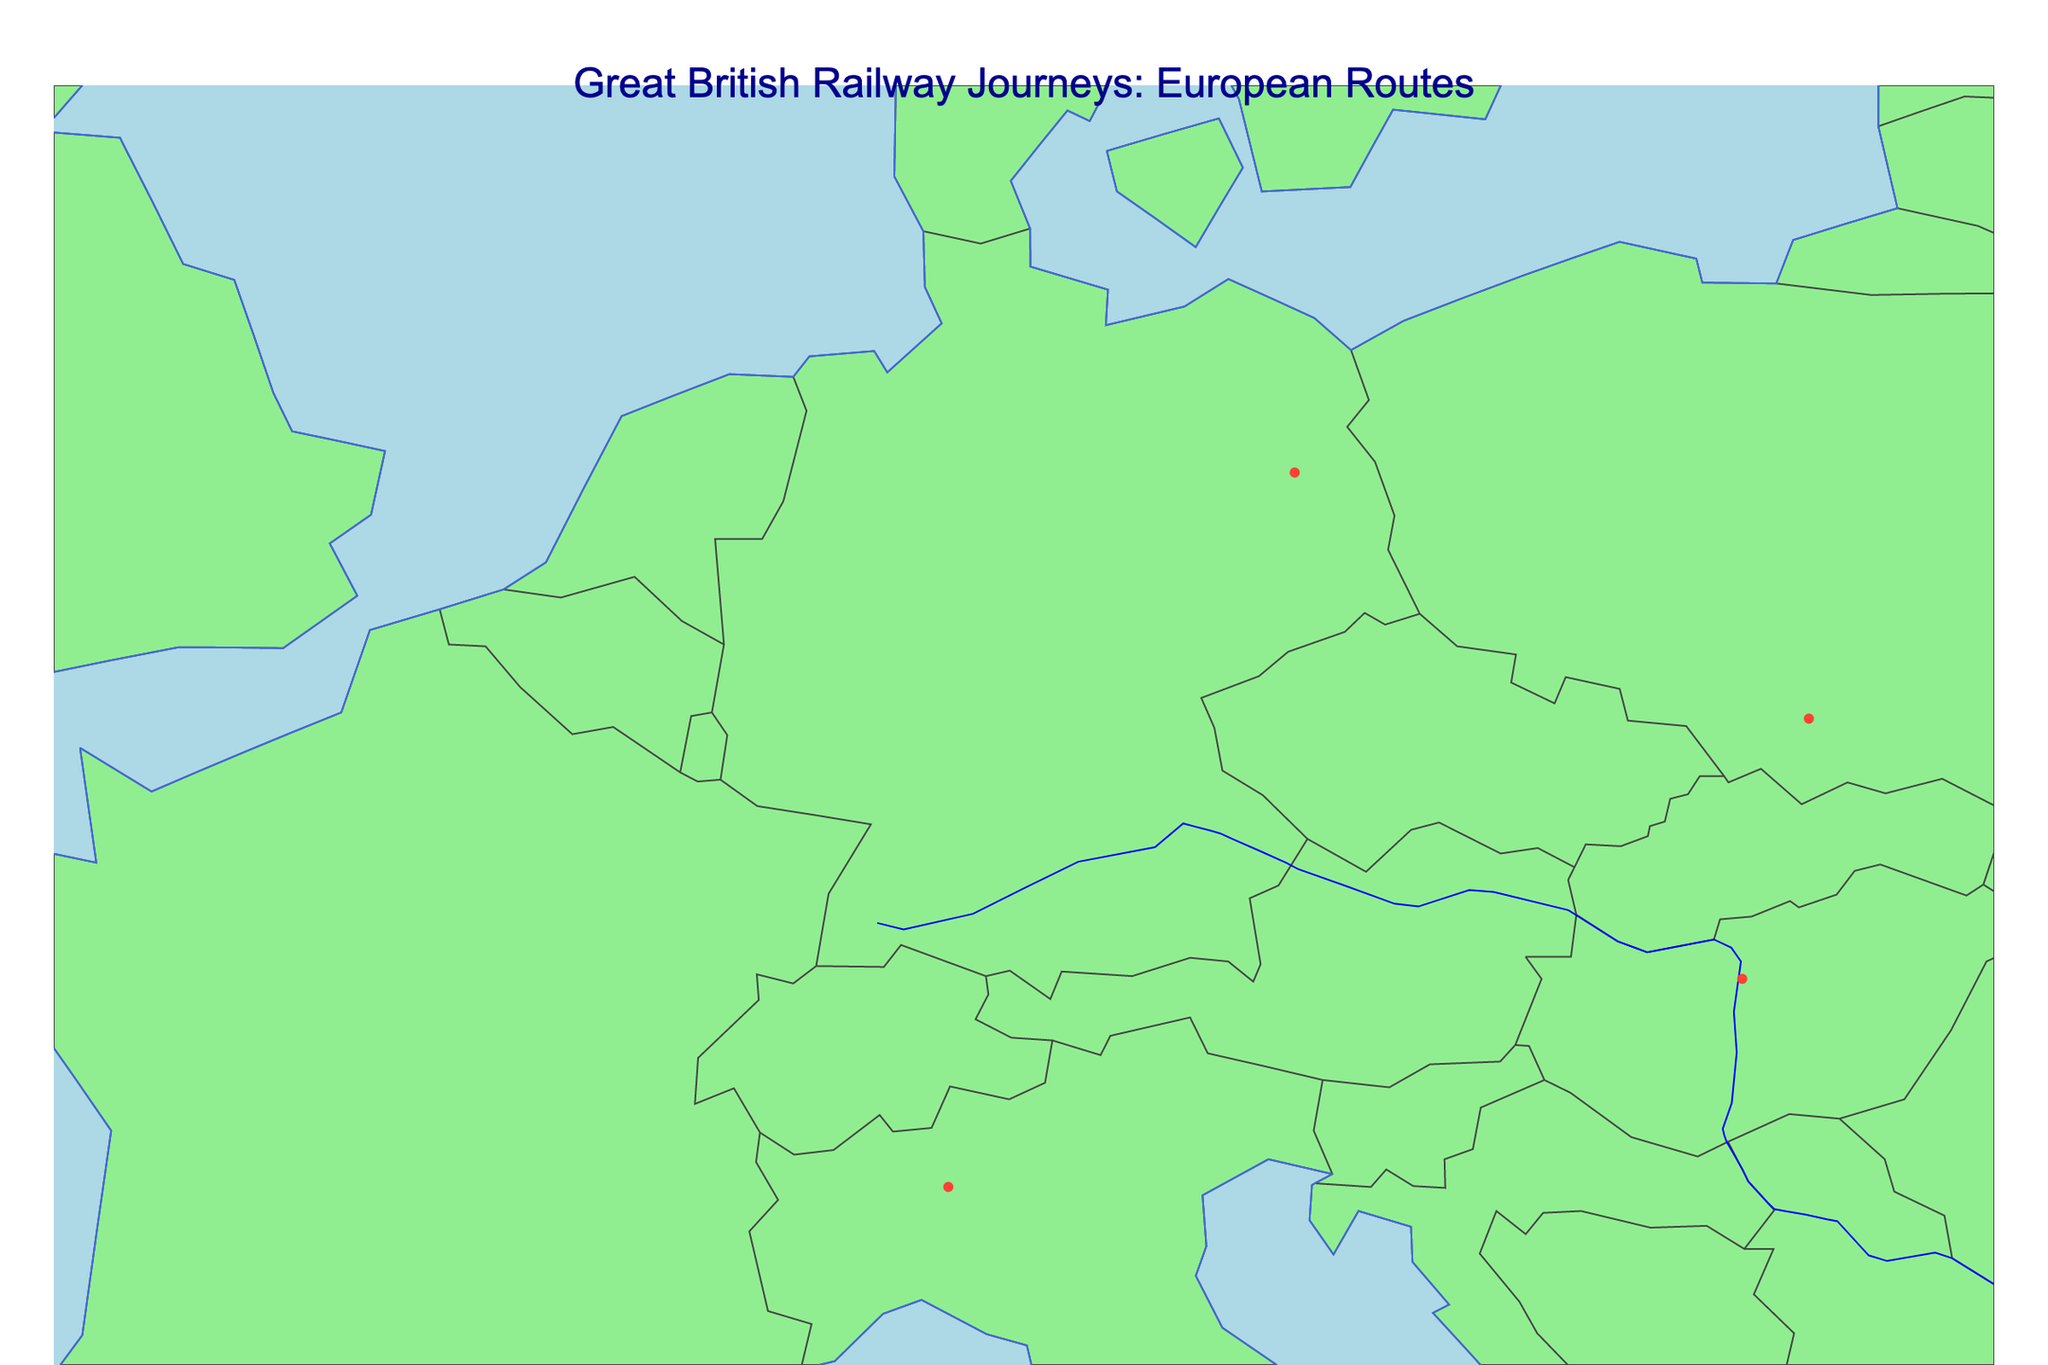Where in Europe is the map centered? The map is centered based on the geographic coordinates provided in the code, which is around latitude 50°N and longitude 10°E, placing it centrally within Europe.
Answer: central Europe What are the colors used in the map for land and ocean? The land is depicted in light green, and the ocean is depicted in light blue.
Answer: light green for land, light blue for ocean How many railway routes are featured in the figure? By counting the number of rows in the data, we find there are 10 railway routes featured in the figure.
Answer: 10 Which two cities mark the start and end of the northernmost route? Among the listed routes, "Glasgow to Inverness" is the northernmost route, with its endpoint in Inverness being at the highest latitude (57.4778°N) on the map.
Answer: Glasgow and Inverness Which railway route connects one of the southernmost endpoints? The route "Barcelona to Madrid" connects Madrid, which is one of the southernmost endpoints on the map.
Answer: Barcelona to Madrid Between "Vienna to Budapest" and "Amsterdam to Berlin," which route is longer based on the geographic endpoints? By estimating the relative positions on the map, the distance between Amsterdam and Berlin appears greater compared to Vienna and Budapest. Hence, "Amsterdam to Berlin" is the longer route.
Answer: Amsterdam to Berlin Which two routes start and end within the same country? The routes "Glasgow to Inverness" and "Barcelona to Madrid" both start and end within the same countries, United Kingdom and Spain, respectively.
Answer: Glasgow to Inverness, Barcelona to Madrid What is the central feature of the title? The title prominently highlights "Great British Railway Journeys: European Routes."
Answer: Great British Railway Journeys: European Routes Which cities are connected by a route in Italy? Two routes have endpoints in Italy: "Paris to Rome" and "Zurich to Milan."
Answer: Rome and Milan How is the width of the route lines customized on the map? The width of the route lines is set to 2, as specified in the code's customization for the line appearance.
Answer: 2 